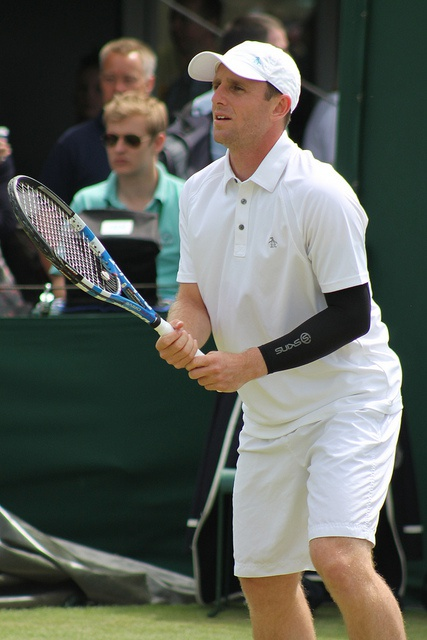Describe the objects in this image and their specific colors. I can see people in black, darkgray, lightgray, and gray tones, people in black, gray, teal, and tan tones, tennis racket in black, darkgray, gray, and lightgray tones, people in black, gray, brown, and tan tones, and people in black, gray, darkgray, and teal tones in this image. 